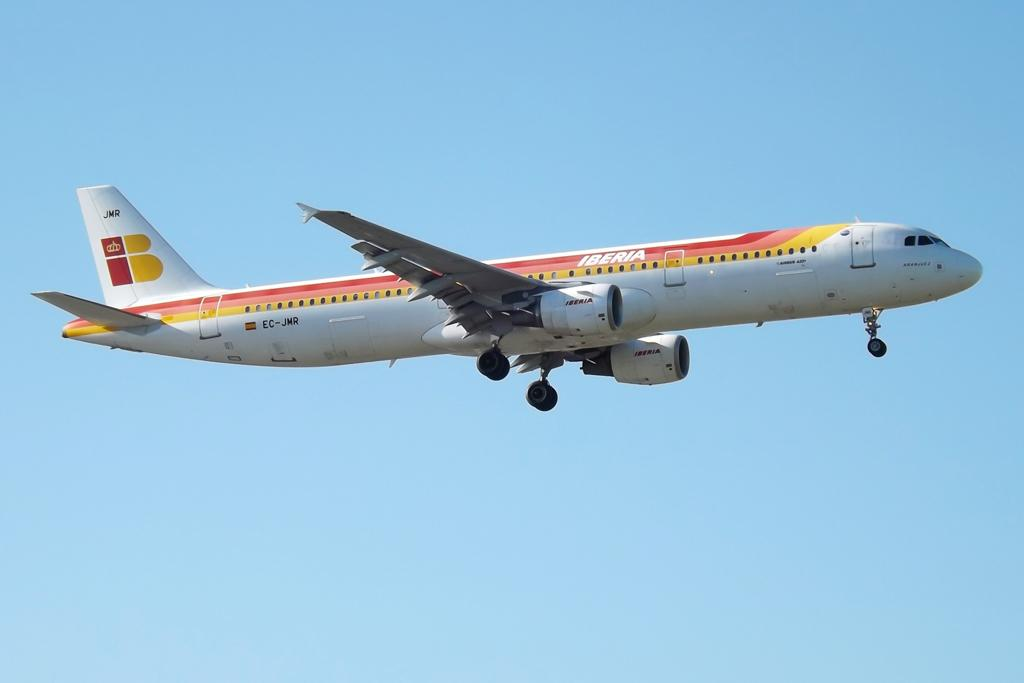<image>
Offer a succinct explanation of the picture presented. A red, yellow, pink and white airplane from the company Iberia 